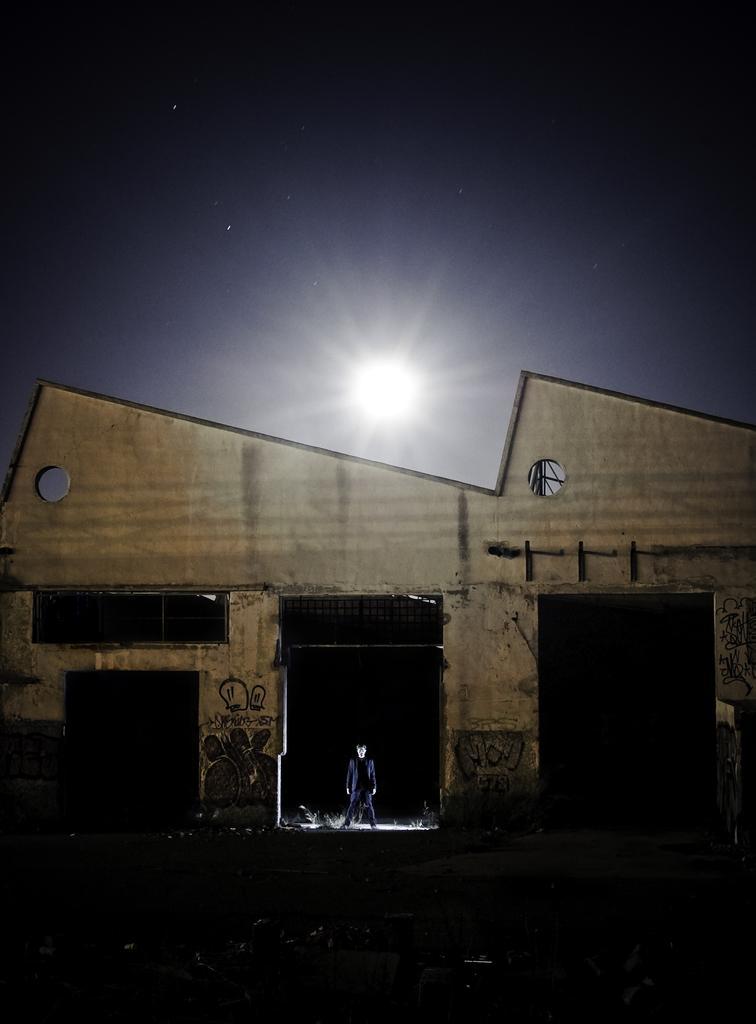How would you summarize this image in a sentence or two? In this image, we can see a house with walls, grills and some paintings. Here a person is standing. Background there is a dark view. 